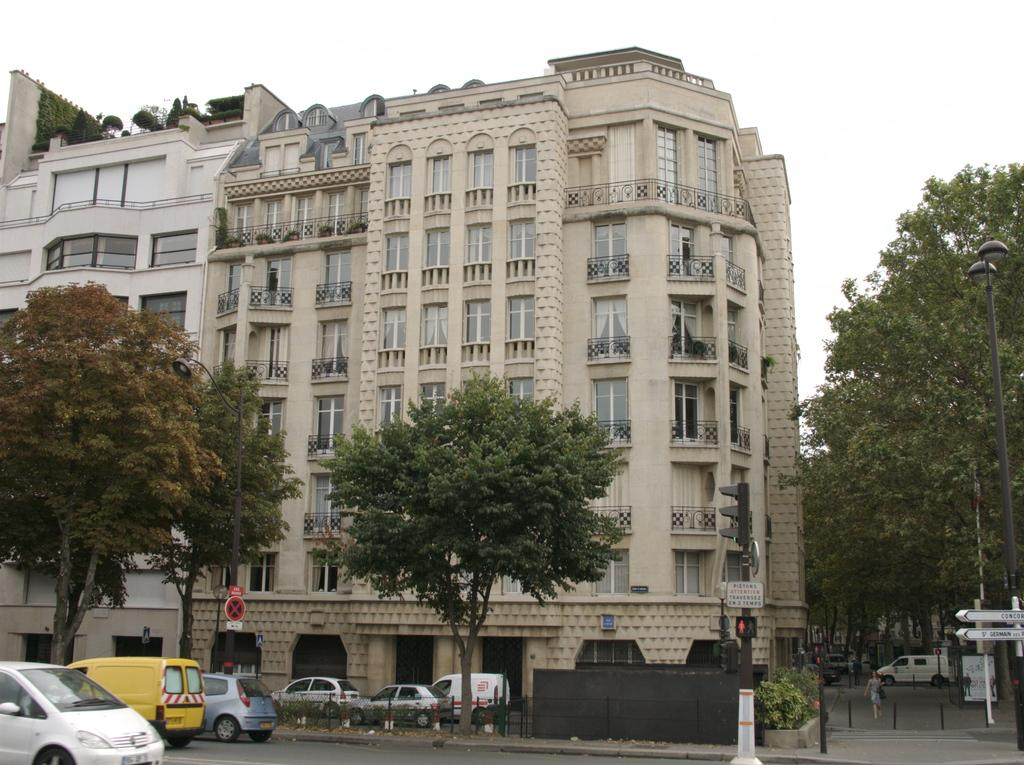What type of structures can be seen in the image? There are buildings in the image. What other natural elements are present in the image? There are trees in the image. What objects can be seen on the ground in the image? There are boards and poles in the image. Is there any human presence in the image? Yes, there is a person in the image. What can be seen on the road in the image? There are vehicles on the road in the image. What is visible at the top of the image? The sky is visible at the top of the image. How many cushions are present on the person in the image? There are no cushions visible on the person in the image. Is there any sleet falling in the image? There is no mention of sleet or any weather condition in the image. 